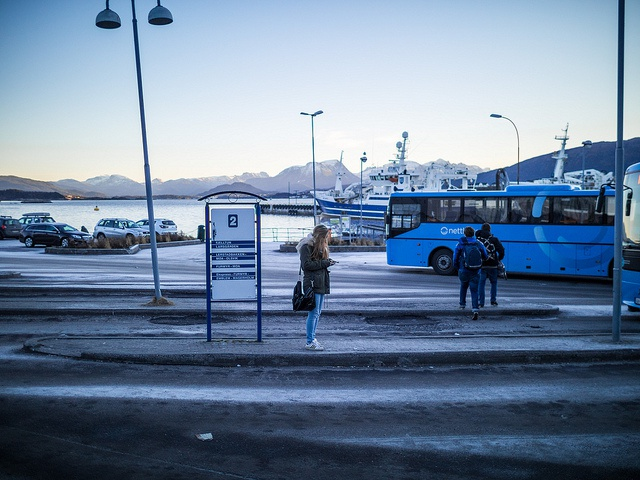Describe the objects in this image and their specific colors. I can see bus in blue, black, and navy tones, boat in blue, darkgray, lightblue, and gray tones, bus in blue, black, and darkgray tones, people in blue, black, gray, and navy tones, and people in blue, black, navy, and darkblue tones in this image. 